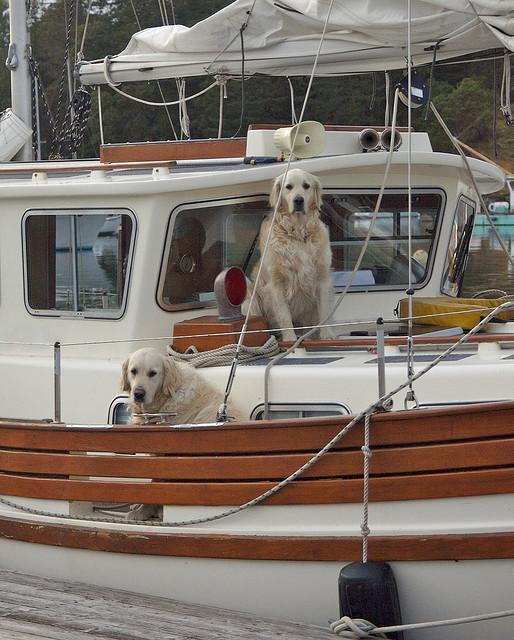How many dogs are riding on the boat?
Answer briefly. 2. What color is this boat?
Be succinct. White. Are the dogs well-behaved?
Quick response, please. Yes. 